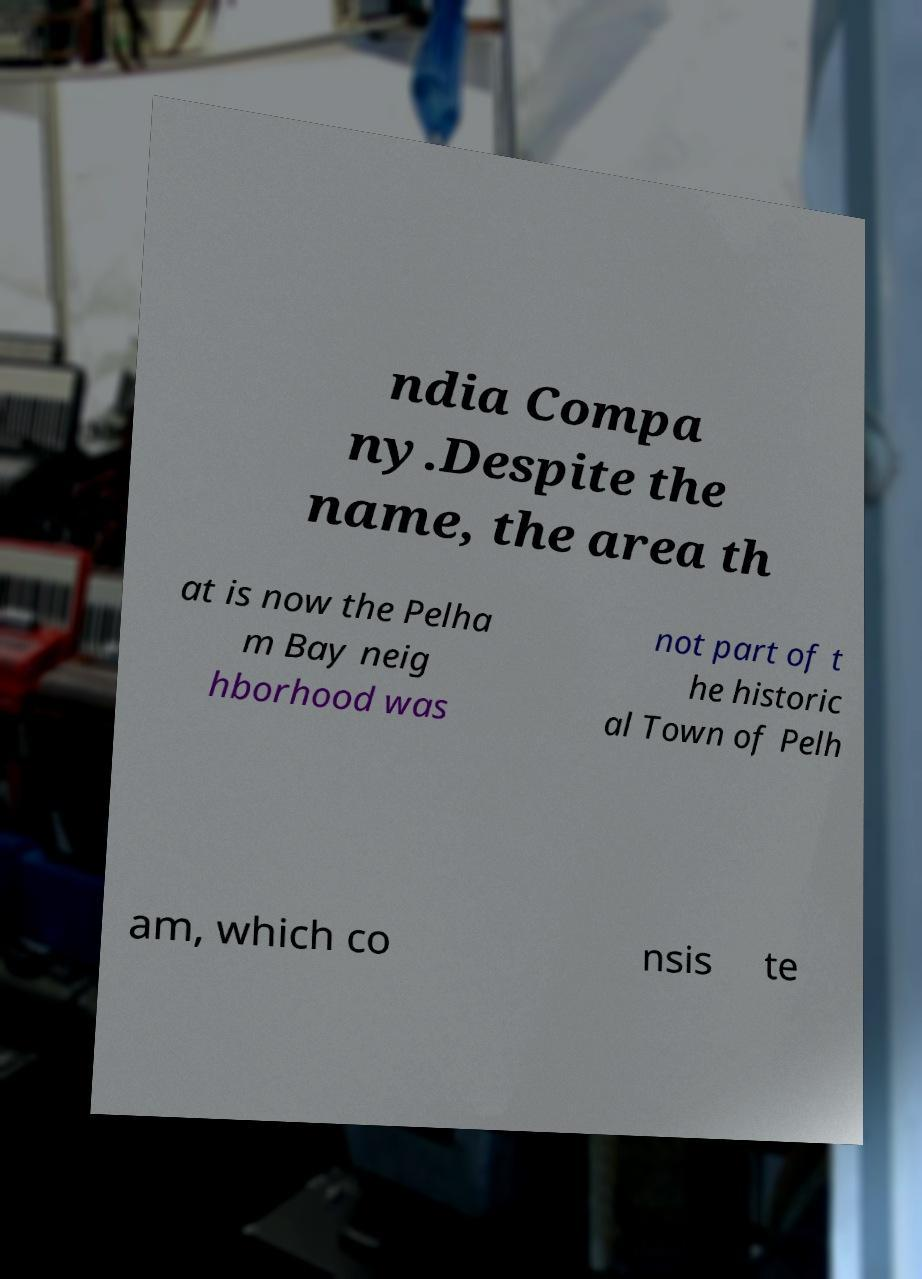Can you accurately transcribe the text from the provided image for me? ndia Compa ny.Despite the name, the area th at is now the Pelha m Bay neig hborhood was not part of t he historic al Town of Pelh am, which co nsis te 